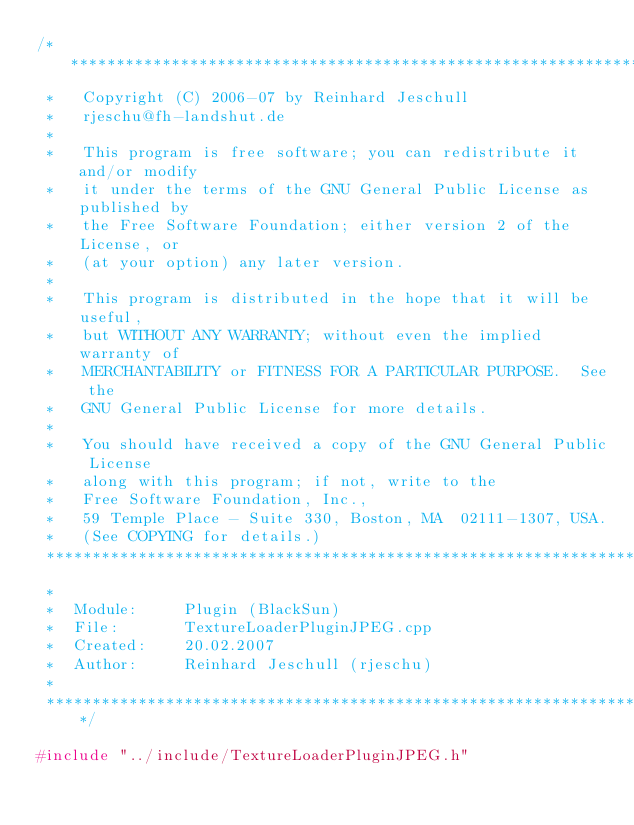Convert code to text. <code><loc_0><loc_0><loc_500><loc_500><_C++_>/***************************************************************************
 *   Copyright (C) 2006-07 by Reinhard Jeschull
 *   rjeschu@fh-landshut.de
 *   
 *   This program is free software; you can redistribute it and/or modify
 *   it under the terms of the GNU General Public License as published by
 *   the Free Software Foundation; either version 2 of the License, or
 *   (at your option) any later version.
 *   
 *   This program is distributed in the hope that it will be useful,
 *   but WITHOUT ANY WARRANTY; without even the implied warranty of
 *   MERCHANTABILITY or FITNESS FOR A PARTICULAR PURPOSE.  See the
 *   GNU General Public License for more details.
 *   
 *   You should have received a copy of the GNU General Public License
 *   along with this program; if not, write to the
 *   Free Software Foundation, Inc.,
 *   59 Temple Place - Suite 330, Boston, MA  02111-1307, USA.
 *   (See COPYING for details.)
 ***************************************************************************
 *
 *  Module:     Plugin (BlackSun)
 *  File:       TextureLoaderPluginJPEG.cpp
 *  Created:    20.02.2007
 *  Author:     Reinhard Jeschull (rjeschu)
 *
 **************************************************************************/

#include "../include/TextureLoaderPluginJPEG.h"
</code> 